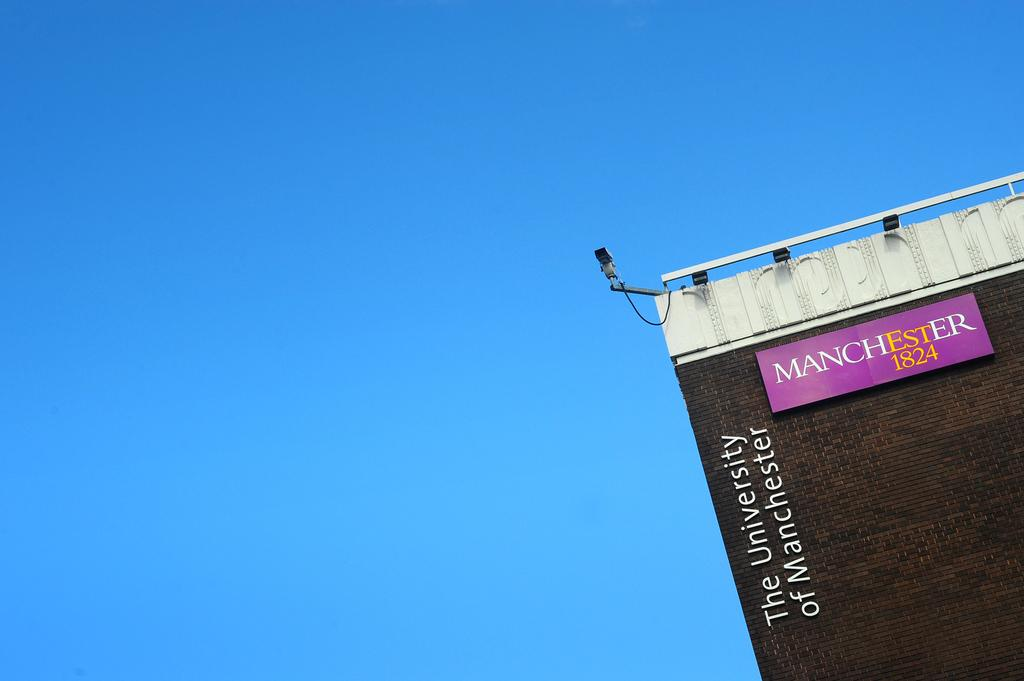<image>
Summarize the visual content of the image. A post on a building wall reading Manchester 1824. 